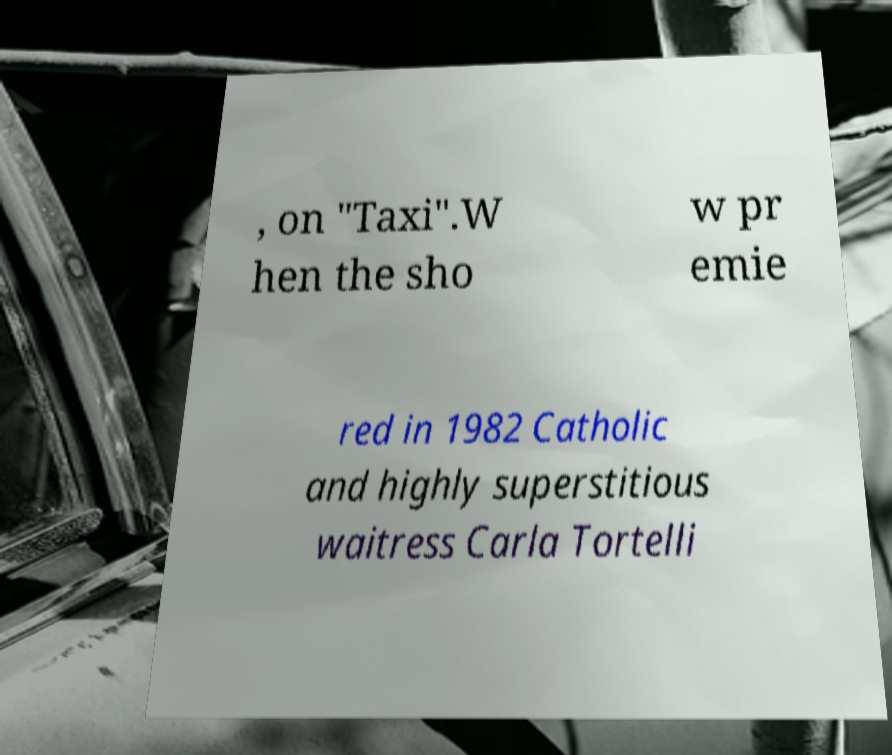There's text embedded in this image that I need extracted. Can you transcribe it verbatim? , on "Taxi".W hen the sho w pr emie red in 1982 Catholic and highly superstitious waitress Carla Tortelli 